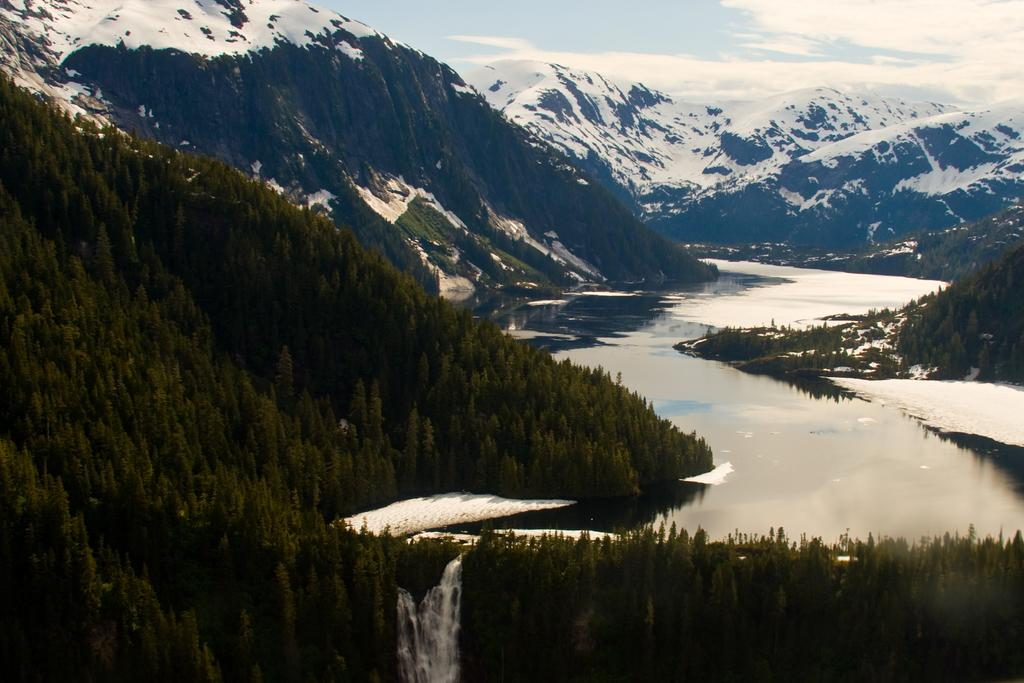What type of vegetation can be seen in the image? There are trees in the image. What natural feature is visible in the image? There is water visible in the image. What type of landscape is depicted in the image? There are hills in the image. What can be seen in the sky in the image? Clouds are present in the image. Can you tell me how many friends are sitting on the hill in the image? There are no people, including friends, present in the image; it only features trees, water, hills, and clouds. 